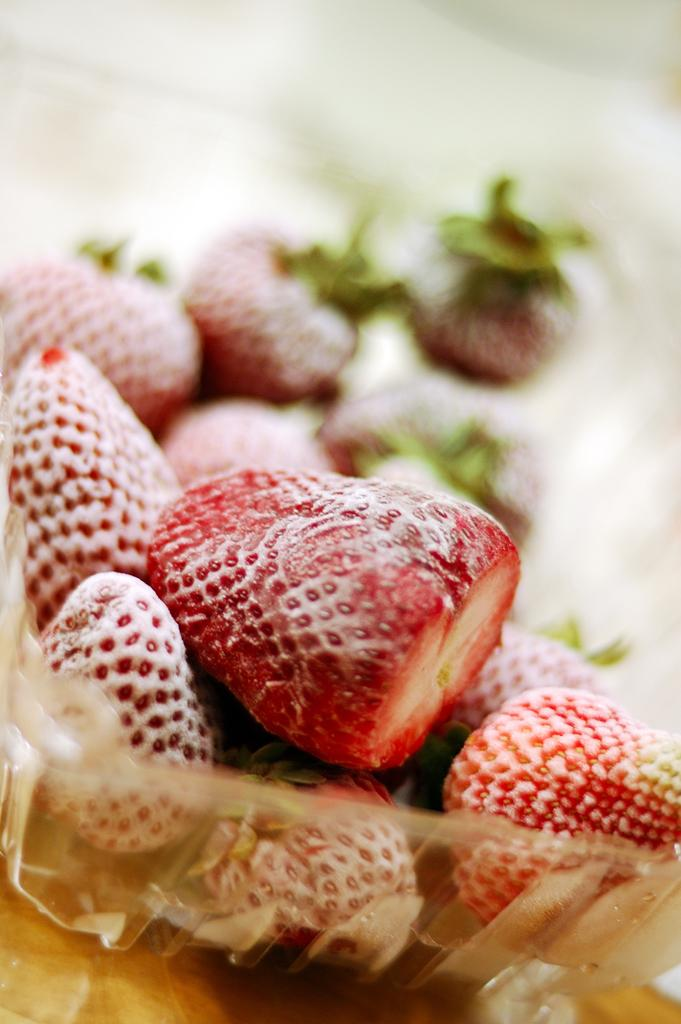What type of fruit is present in the image? There are cherries in the image. How are the cherries contained in the image? The cherries are in a plastic bowl. What type of arch can be seen in the background of the image? There is no arch present in the image; it only features cherries in a plastic bowl. 